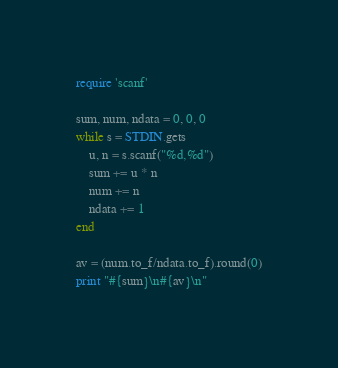Convert code to text. <code><loc_0><loc_0><loc_500><loc_500><_Ruby_>require 'scanf'

sum, num, ndata = 0, 0, 0
while s = STDIN.gets
    u, n = s.scanf("%d,%d")
    sum += u * n
    num += n 
    ndata += 1
end

av = (num.to_f/ndata.to_f).round(0)
print "#{sum}\n#{av}\n"</code> 